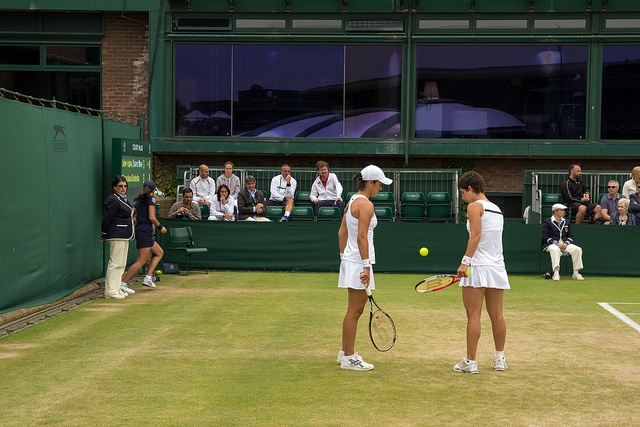Describe the objects in this image and their specific colors. I can see people in darkgreen, lightgray, brown, salmon, and black tones, people in darkgreen, lightgray, brown, gray, and maroon tones, people in darkgreen, black, gray, darkgray, and lightgray tones, people in darkgreen, black, and tan tones, and people in darkgreen, black, brown, and maroon tones in this image. 